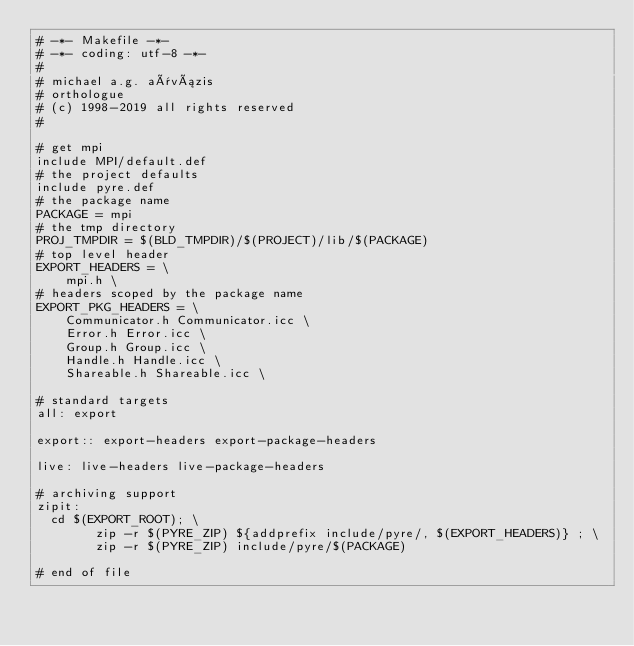<code> <loc_0><loc_0><loc_500><loc_500><_ObjectiveC_># -*- Makefile -*-
# -*- coding: utf-8 -*-
#
# michael a.g. aïvázis
# orthologue
# (c) 1998-2019 all rights reserved
#

# get mpi
include MPI/default.def
# the project defaults
include pyre.def
# the package name
PACKAGE = mpi
# the tmp directory
PROJ_TMPDIR = $(BLD_TMPDIR)/$(PROJECT)/lib/$(PACKAGE)
# top level header
EXPORT_HEADERS = \
    mpi.h \
# headers scoped by the package name
EXPORT_PKG_HEADERS = \
    Communicator.h Communicator.icc \
    Error.h Error.icc \
    Group.h Group.icc \
    Handle.h Handle.icc \
    Shareable.h Shareable.icc \

# standard targets
all: export

export:: export-headers export-package-headers

live: live-headers live-package-headers

# archiving support
zipit:
	cd $(EXPORT_ROOT); \
        zip -r $(PYRE_ZIP) ${addprefix include/pyre/, $(EXPORT_HEADERS)} ; \
        zip -r $(PYRE_ZIP) include/pyre/$(PACKAGE)

# end of file
</code> 